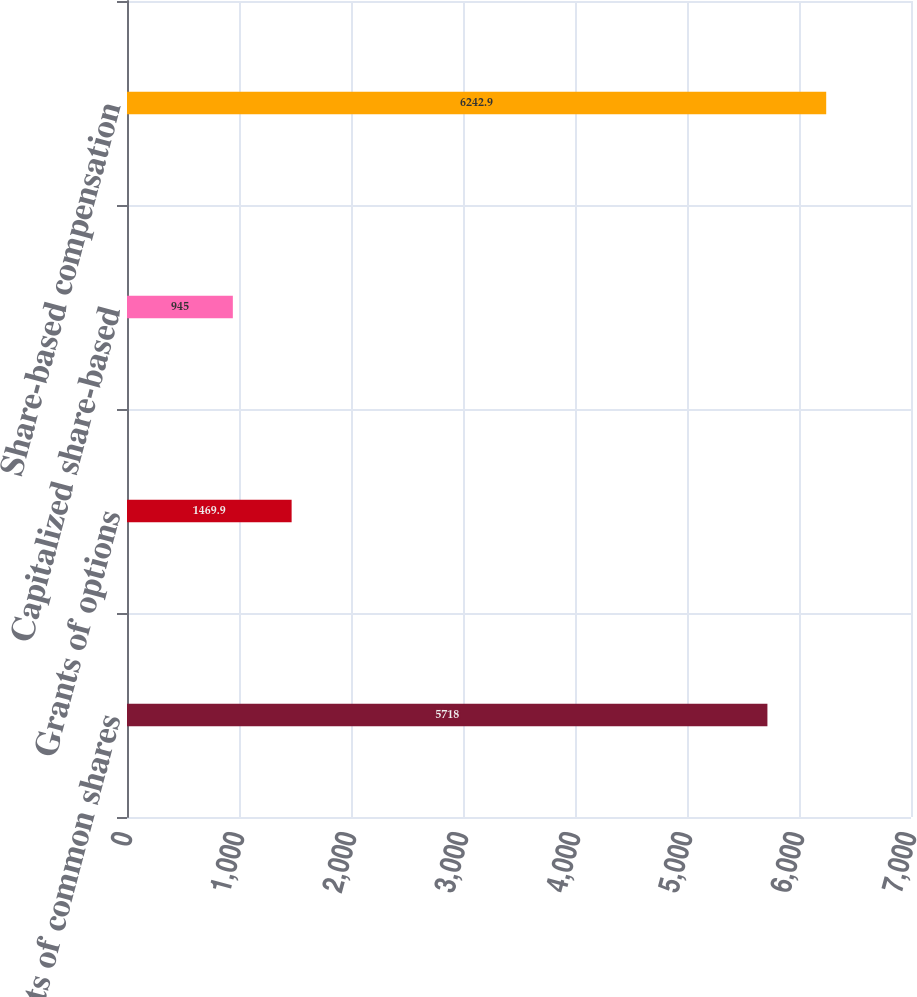Convert chart. <chart><loc_0><loc_0><loc_500><loc_500><bar_chart><fcel>Grants of common shares<fcel>Grants of options<fcel>Capitalized share-based<fcel>Share-based compensation<nl><fcel>5718<fcel>1469.9<fcel>945<fcel>6242.9<nl></chart> 